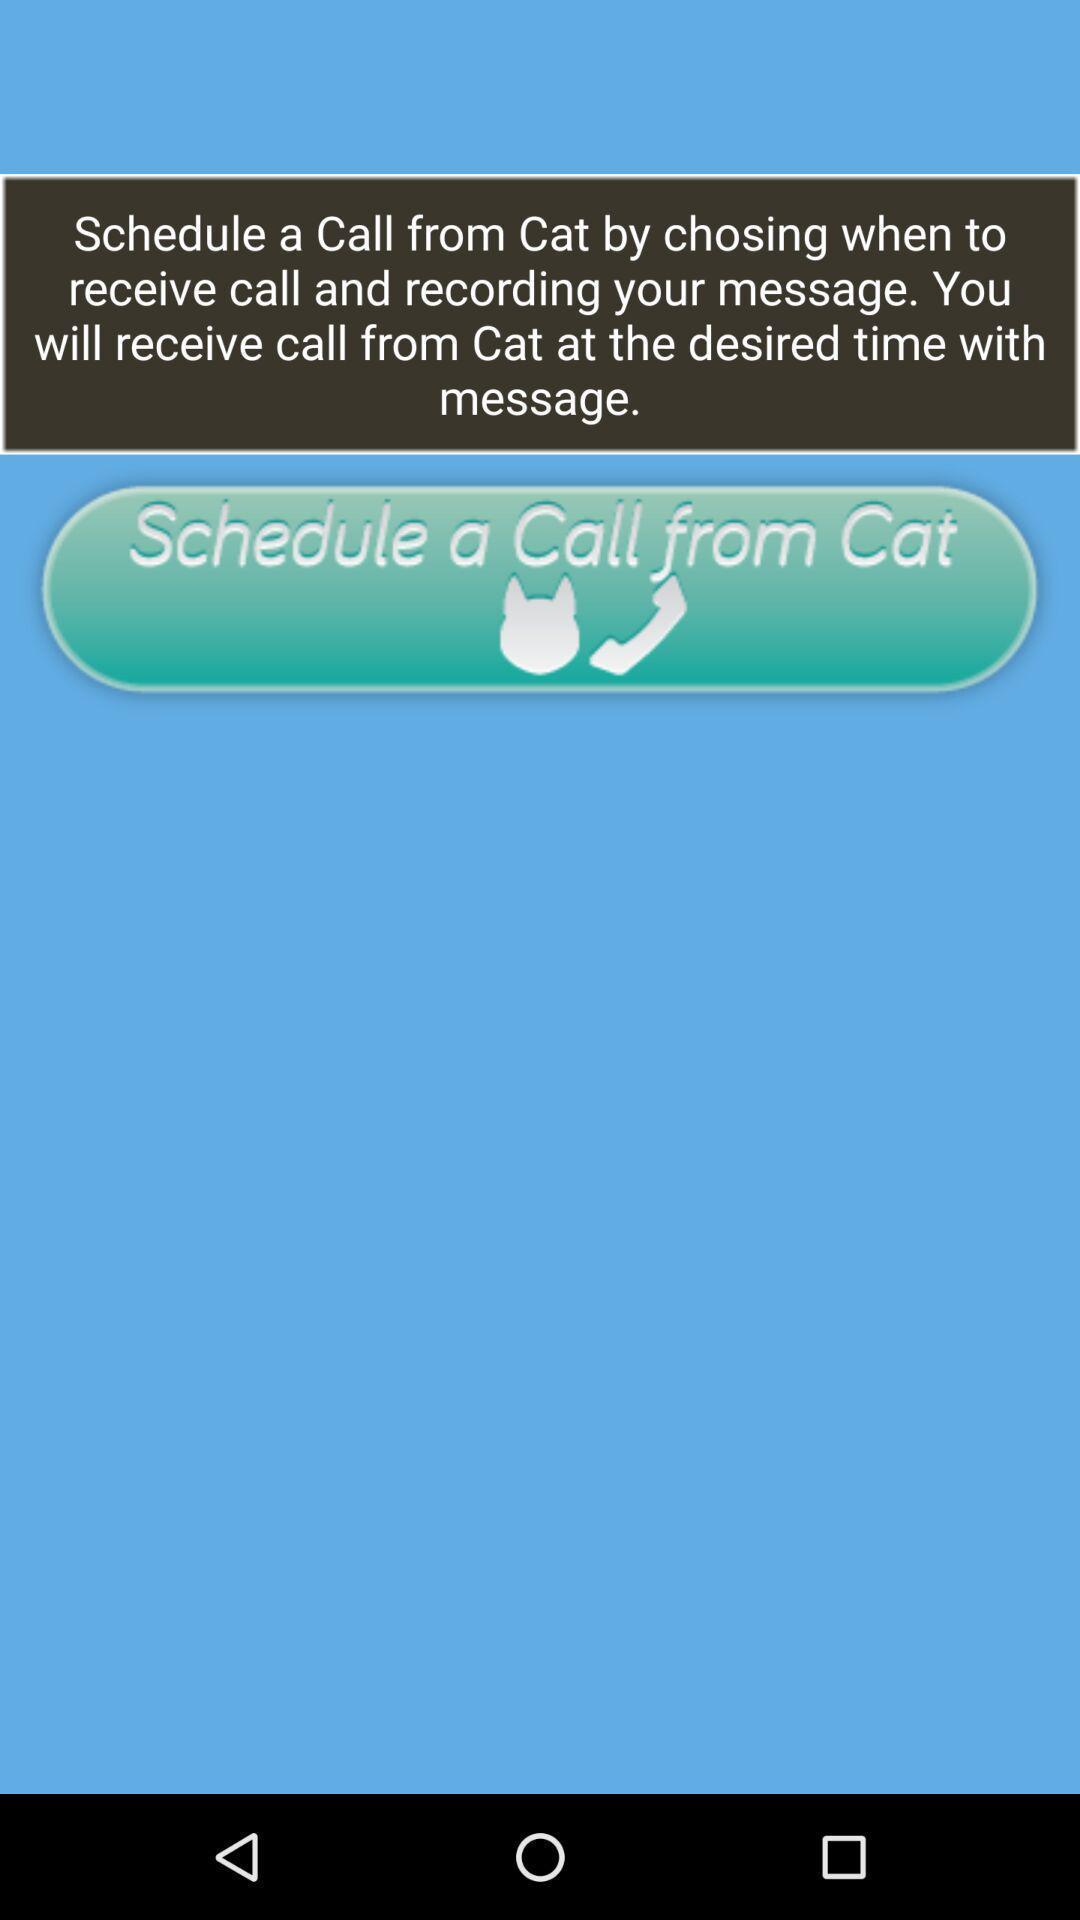Provide a description of this screenshot. Window displaying is about calls. 